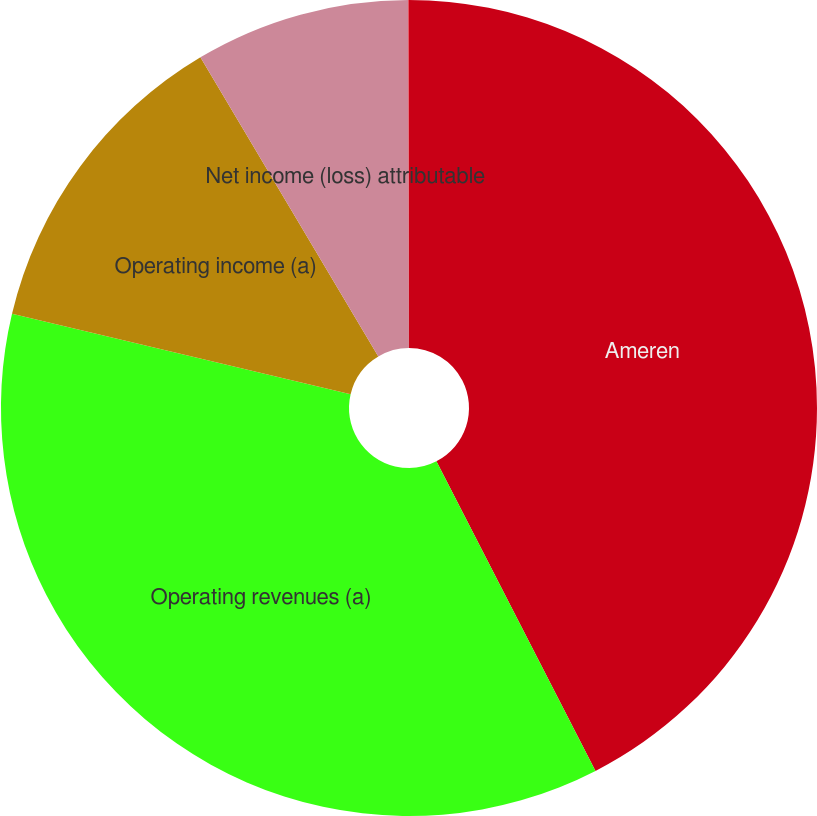Convert chart. <chart><loc_0><loc_0><loc_500><loc_500><pie_chart><fcel>Ameren<fcel>Operating revenues (a)<fcel>Operating income (a)<fcel>Net income (loss) attributable<fcel>Earnings (loss) per common<nl><fcel>42.44%<fcel>36.26%<fcel>12.75%<fcel>8.51%<fcel>0.03%<nl></chart> 